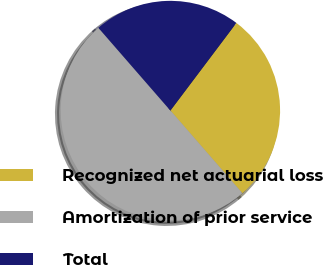Convert chart. <chart><loc_0><loc_0><loc_500><loc_500><pie_chart><fcel>Recognized net actuarial loss<fcel>Amortization of prior service<fcel>Total<nl><fcel>28.33%<fcel>50.0%<fcel>21.67%<nl></chart> 